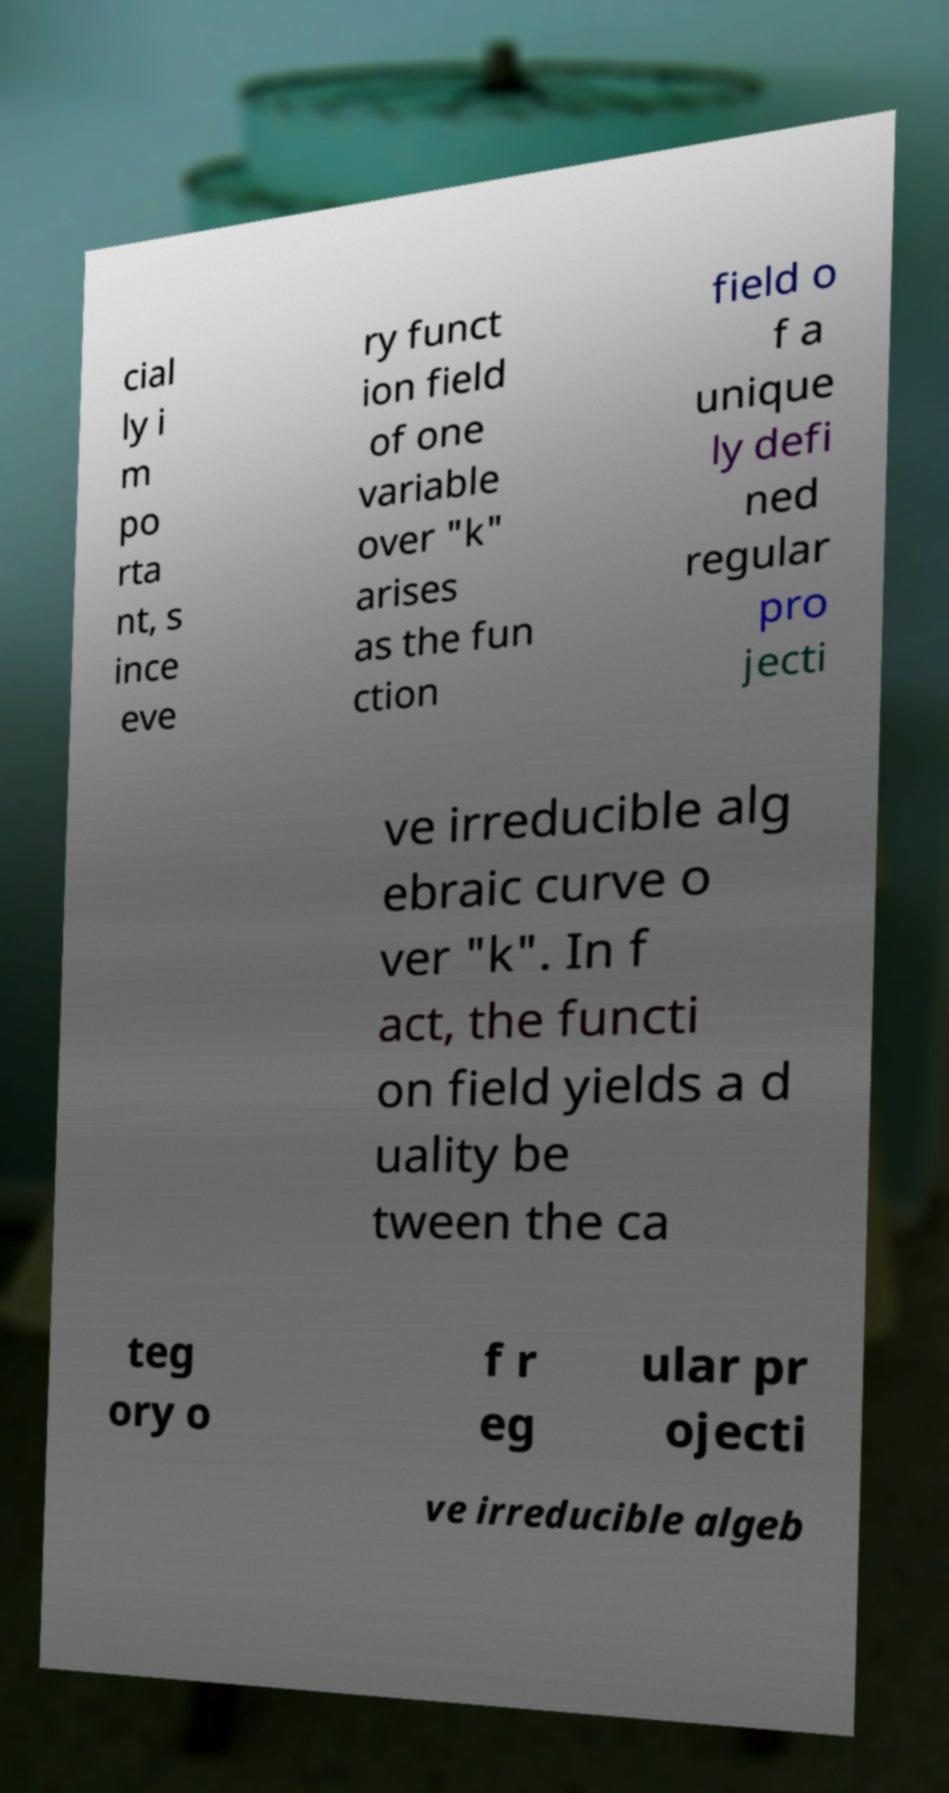Could you assist in decoding the text presented in this image and type it out clearly? cial ly i m po rta nt, s ince eve ry funct ion field of one variable over "k" arises as the fun ction field o f a unique ly defi ned regular pro jecti ve irreducible alg ebraic curve o ver "k". In f act, the functi on field yields a d uality be tween the ca teg ory o f r eg ular pr ojecti ve irreducible algeb 